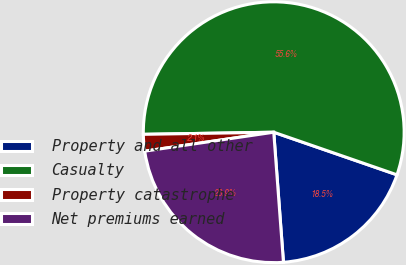<chart> <loc_0><loc_0><loc_500><loc_500><pie_chart><fcel>Property and all other<fcel>Casualty<fcel>Property catastrophe<fcel>Net premiums earned<nl><fcel>18.52%<fcel>55.56%<fcel>2.06%<fcel>23.87%<nl></chart> 